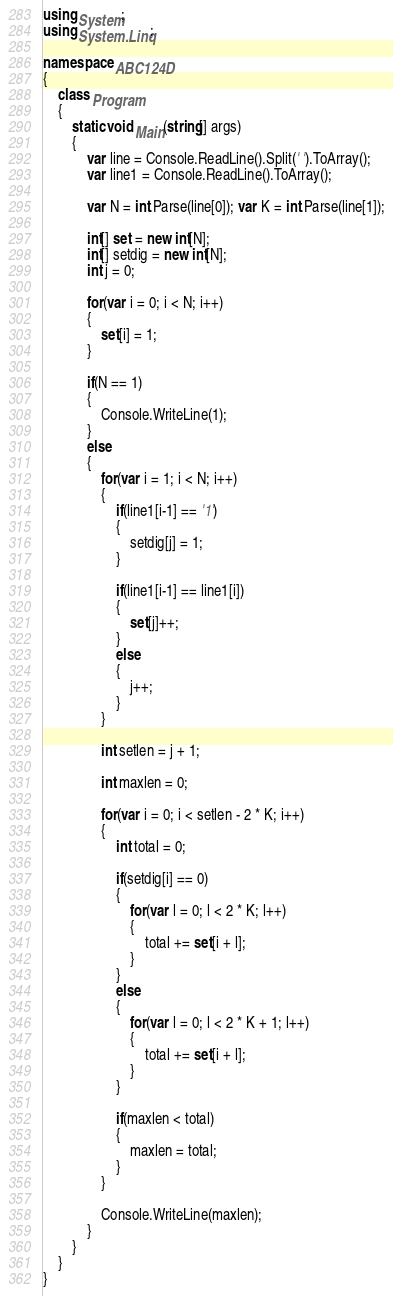Convert code to text. <code><loc_0><loc_0><loc_500><loc_500><_C#_>using System;
using System.Linq;

namespace ABC124D
{
    class Program
    {
        static void Main(string[] args)
        {
            var line = Console.ReadLine().Split(' ').ToArray();
            var line1 = Console.ReadLine().ToArray();

            var N = int.Parse(line[0]); var K = int.Parse(line[1]);

            int[] set = new int[N];
            int[] setdig = new int[N];
            int j = 0;

            for(var i = 0; i < N; i++)
            {
                set[i] = 1;
            }

            if(N == 1)
            {
                Console.WriteLine(1);
            }
            else
            {
                for(var i = 1; i < N; i++)
                {
                    if(line1[i-1] == '1')
                    {
                        setdig[j] = 1;
                    }

                    if(line1[i-1] == line1[i])
                    {
                        set[j]++;
                    }
                    else
                    {
                        j++;
                    }
                }

                int setlen = j + 1;

                int maxlen = 0;

                for(var i = 0; i < setlen - 2 * K; i++)
                {
                    int total = 0;

                    if(setdig[i] == 0)
                    {
                        for(var l = 0; l < 2 * K; l++)
                        {
                            total += set[i + l];
                        }
                    }
                    else
                    {
                        for(var l = 0; l < 2 * K + 1; l++)
                        {
                            total += set[i + l];
                        }
                    }

                    if(maxlen < total)
                    {
                        maxlen = total;
                    }
                }

                Console.WriteLine(maxlen);
            }
        }
    }
}
</code> 